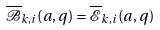Convert formula to latex. <formula><loc_0><loc_0><loc_500><loc_500>\overline { \mathcal { B } } _ { k , i } ( a , q ) = \overline { \mathcal { E } } _ { k , i } ( a , q )</formula> 